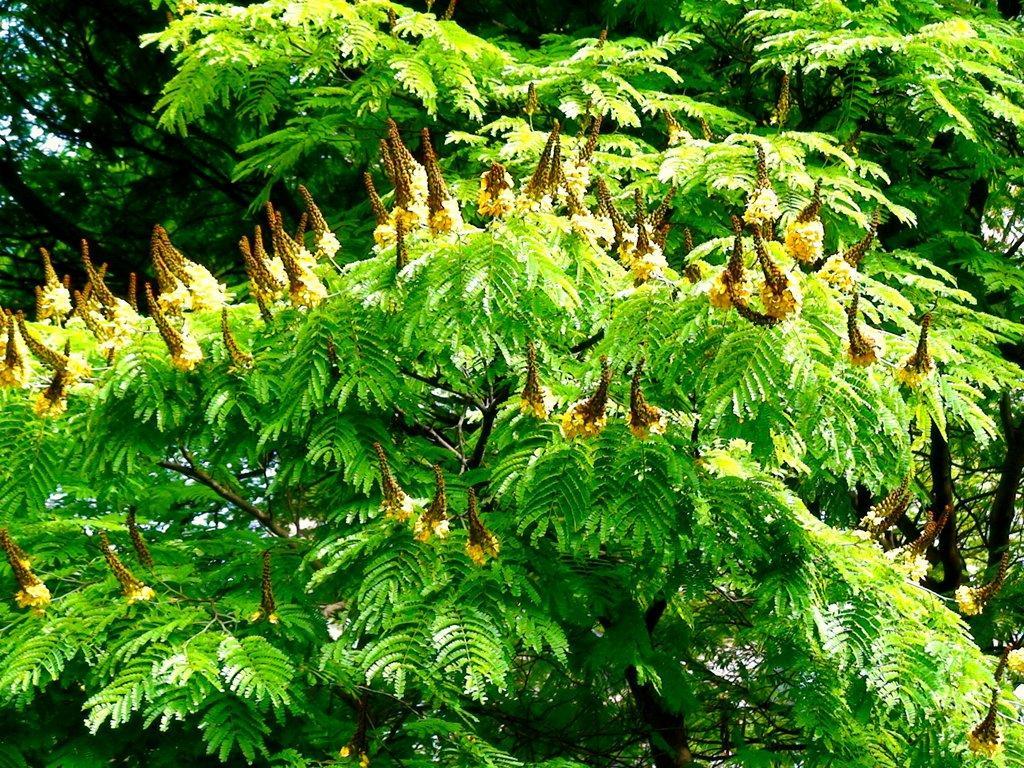Please provide a concise description of this image. In the image there are trees with leaves and also there are yellow flowers. 